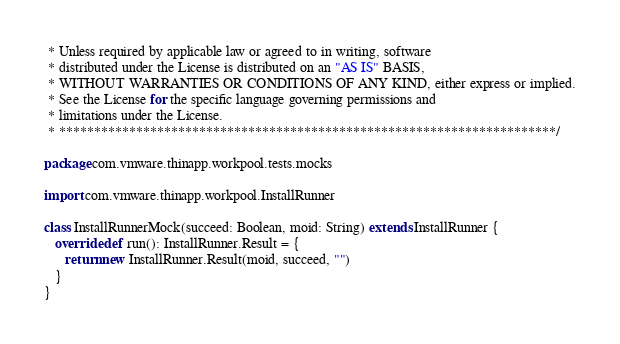<code> <loc_0><loc_0><loc_500><loc_500><_Scala_> * Unless required by applicable law or agreed to in writing, software
 * distributed under the License is distributed on an "AS IS" BASIS,
 * WITHOUT WARRANTIES OR CONDITIONS OF ANY KIND, either express or implied.
 * See the License for the specific language governing permissions and
 * limitations under the License.
 * ***********************************************************************/

package com.vmware.thinapp.workpool.tests.mocks

import com.vmware.thinapp.workpool.InstallRunner

class InstallRunnerMock(succeed: Boolean, moid: String) extends InstallRunner {
   override def run(): InstallRunner.Result = {
      return new InstallRunner.Result(moid, succeed, "")
   }
}
</code> 